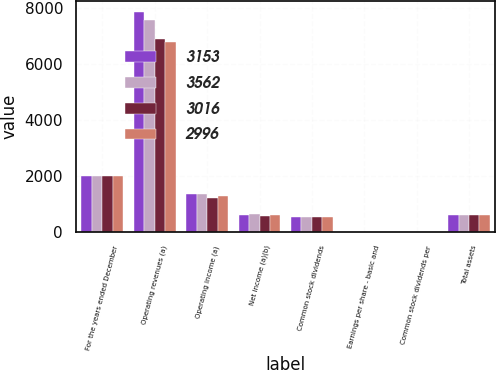Convert chart to OTSL. <chart><loc_0><loc_0><loc_500><loc_500><stacked_bar_chart><ecel><fcel>For the years ended December<fcel>Operating revenues (a)<fcel>Operating income (a)<fcel>Net income (a)(b)<fcel>Common stock dividends<fcel>Earnings per share - basic and<fcel>Common stock dividends per<fcel>Total assets<nl><fcel>3153<fcel>2008<fcel>7839<fcel>1362<fcel>605<fcel>534<fcel>2.88<fcel>2.54<fcel>605.5<nl><fcel>3562<fcel>2007<fcel>7562<fcel>1359<fcel>618<fcel>527<fcel>2.98<fcel>2.54<fcel>605.5<nl><fcel>3016<fcel>2006<fcel>6895<fcel>1188<fcel>547<fcel>522<fcel>2.66<fcel>2.54<fcel>605.5<nl><fcel>2996<fcel>2005<fcel>6780<fcel>1284<fcel>606<fcel>511<fcel>3.02<fcel>2.54<fcel>605.5<nl></chart> 